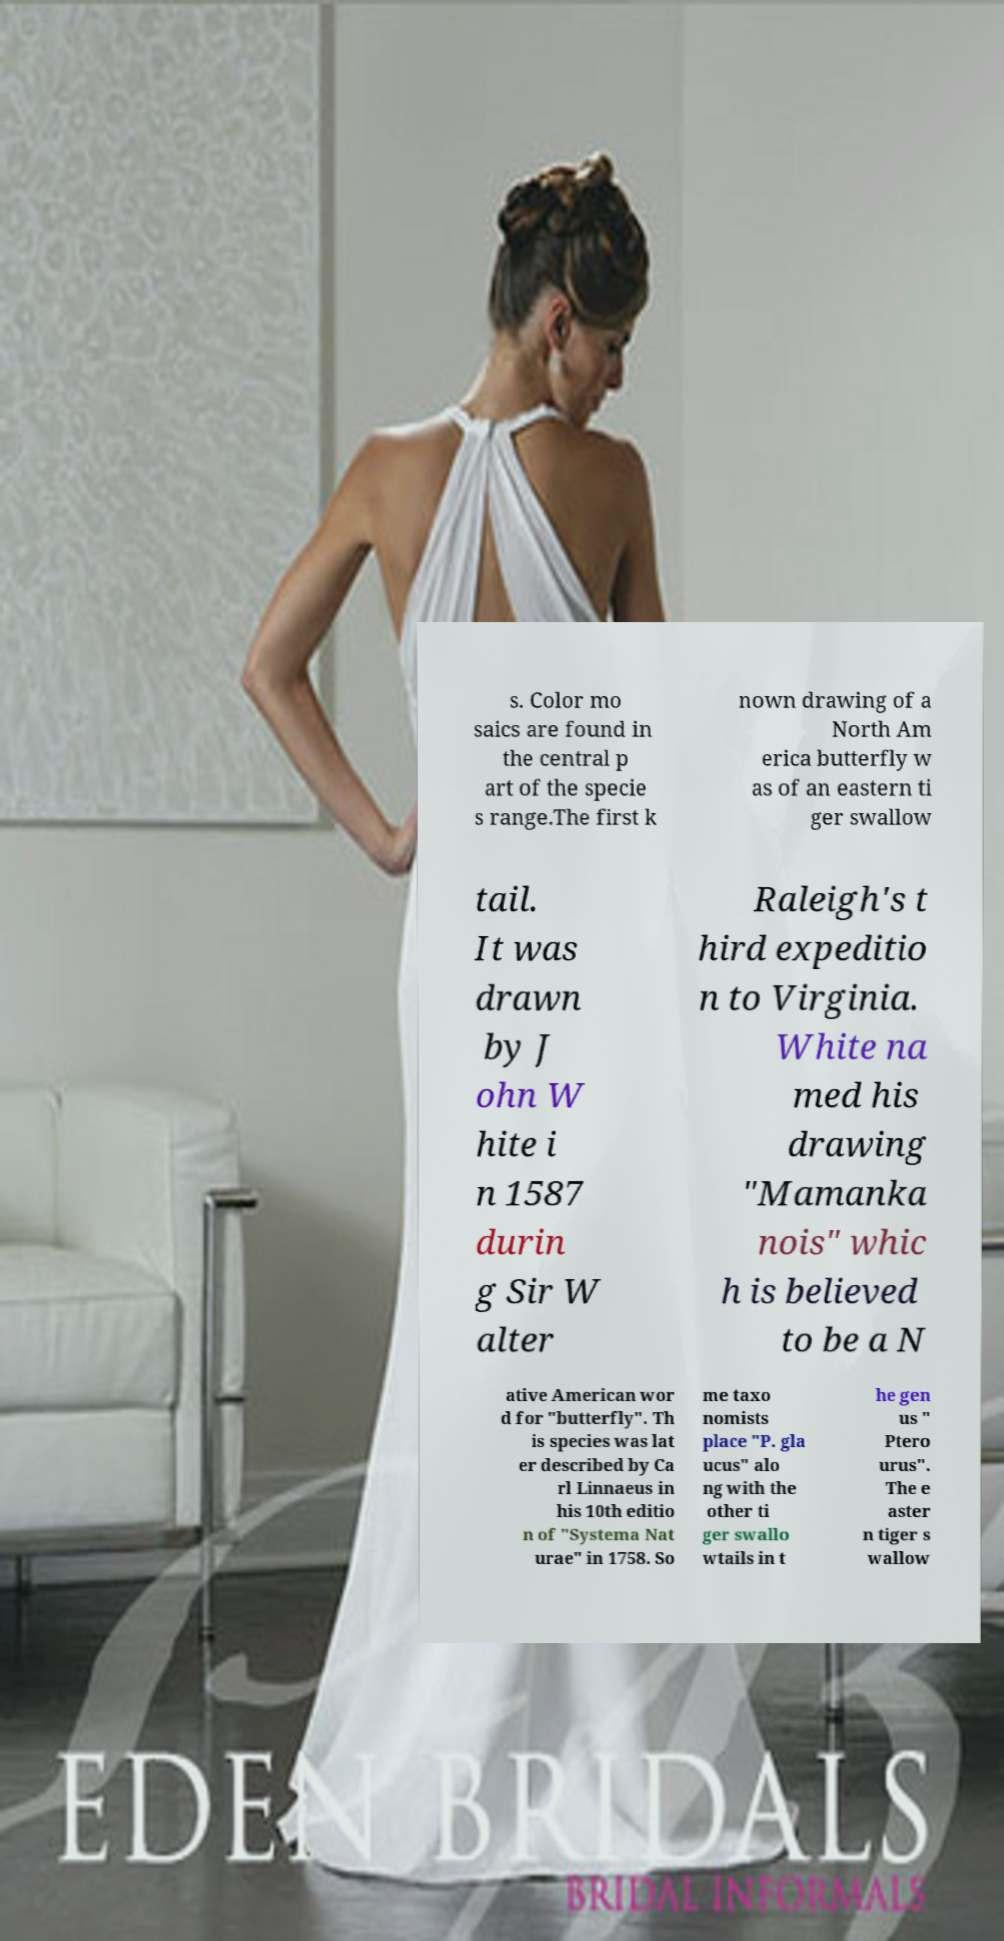What messages or text are displayed in this image? I need them in a readable, typed format. s. Color mo saics are found in the central p art of the specie s range.The first k nown drawing of a North Am erica butterfly w as of an eastern ti ger swallow tail. It was drawn by J ohn W hite i n 1587 durin g Sir W alter Raleigh's t hird expeditio n to Virginia. White na med his drawing "Mamanka nois" whic h is believed to be a N ative American wor d for "butterfly". Th is species was lat er described by Ca rl Linnaeus in his 10th editio n of "Systema Nat urae" in 1758. So me taxo nomists place "P. gla ucus" alo ng with the other ti ger swallo wtails in t he gen us " Ptero urus". The e aster n tiger s wallow 